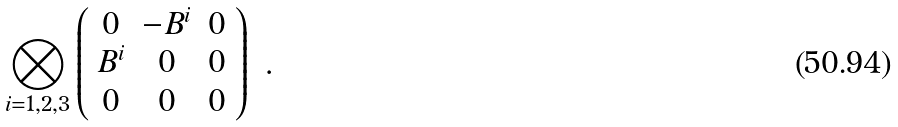<formula> <loc_0><loc_0><loc_500><loc_500>\bigotimes _ { i = 1 , 2 , 3 } \left ( \begin{array} { c c c } 0 & - B ^ { i } & 0 \\ B ^ { i } & 0 & 0 \\ 0 & 0 & 0 \end{array} \right ) \ .</formula> 